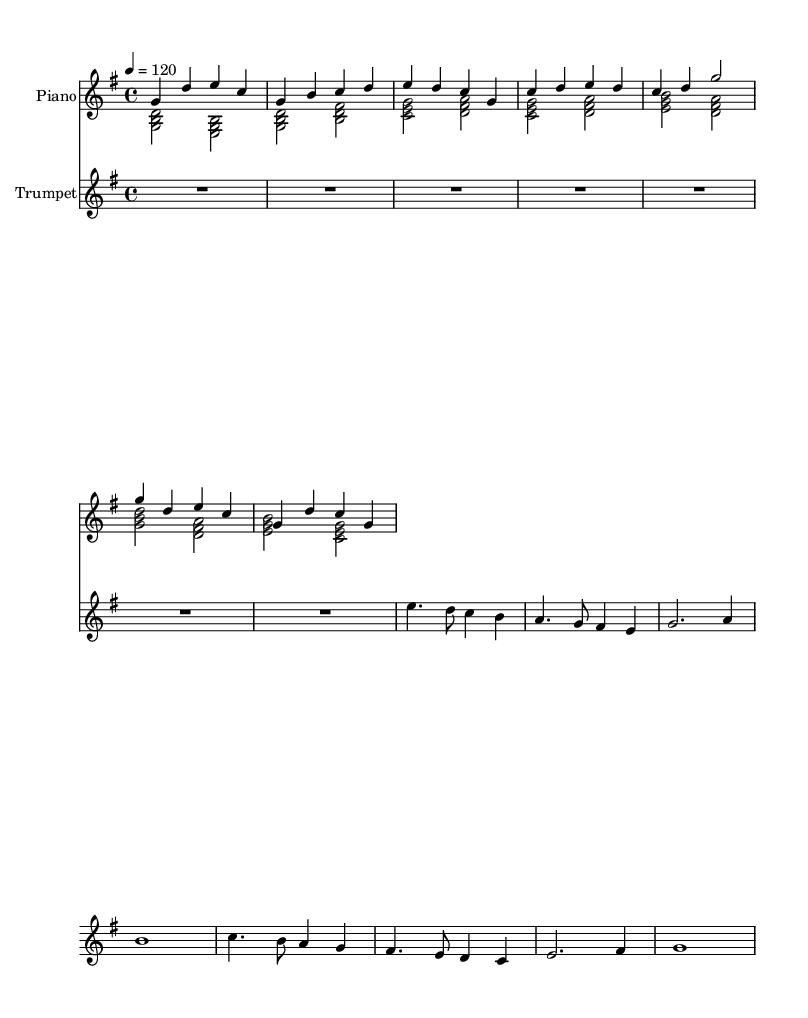What is the key signature of this music? The key signature is G major, which contains one sharp (F#).
Answer: G major What is the time signature of this piece? The time signature is indicated as 4/4, which means there are four beats per measure.
Answer: 4/4 What is the tempo marking for this piece? The tempo is set at a quarter note equals 120 beats per minute, indicating a moderately fast pace.
Answer: 120 How many measures are in the intro section? The intro consists of 2 measures based on the provided music notation.
Answer: 2 What instruments are included in this score? The score includes a piano (both right and left hand) and a trumpet.
Answer: Piano and Trumpet In which section does the trumpet solo occur? The trumpet solo is specifically found in the bridge section of the music.
Answer: Bridge How many notes are played in the trumpet solo on the first measure? The first measure of the trumpet solo has 4 notes played.
Answer: 4 